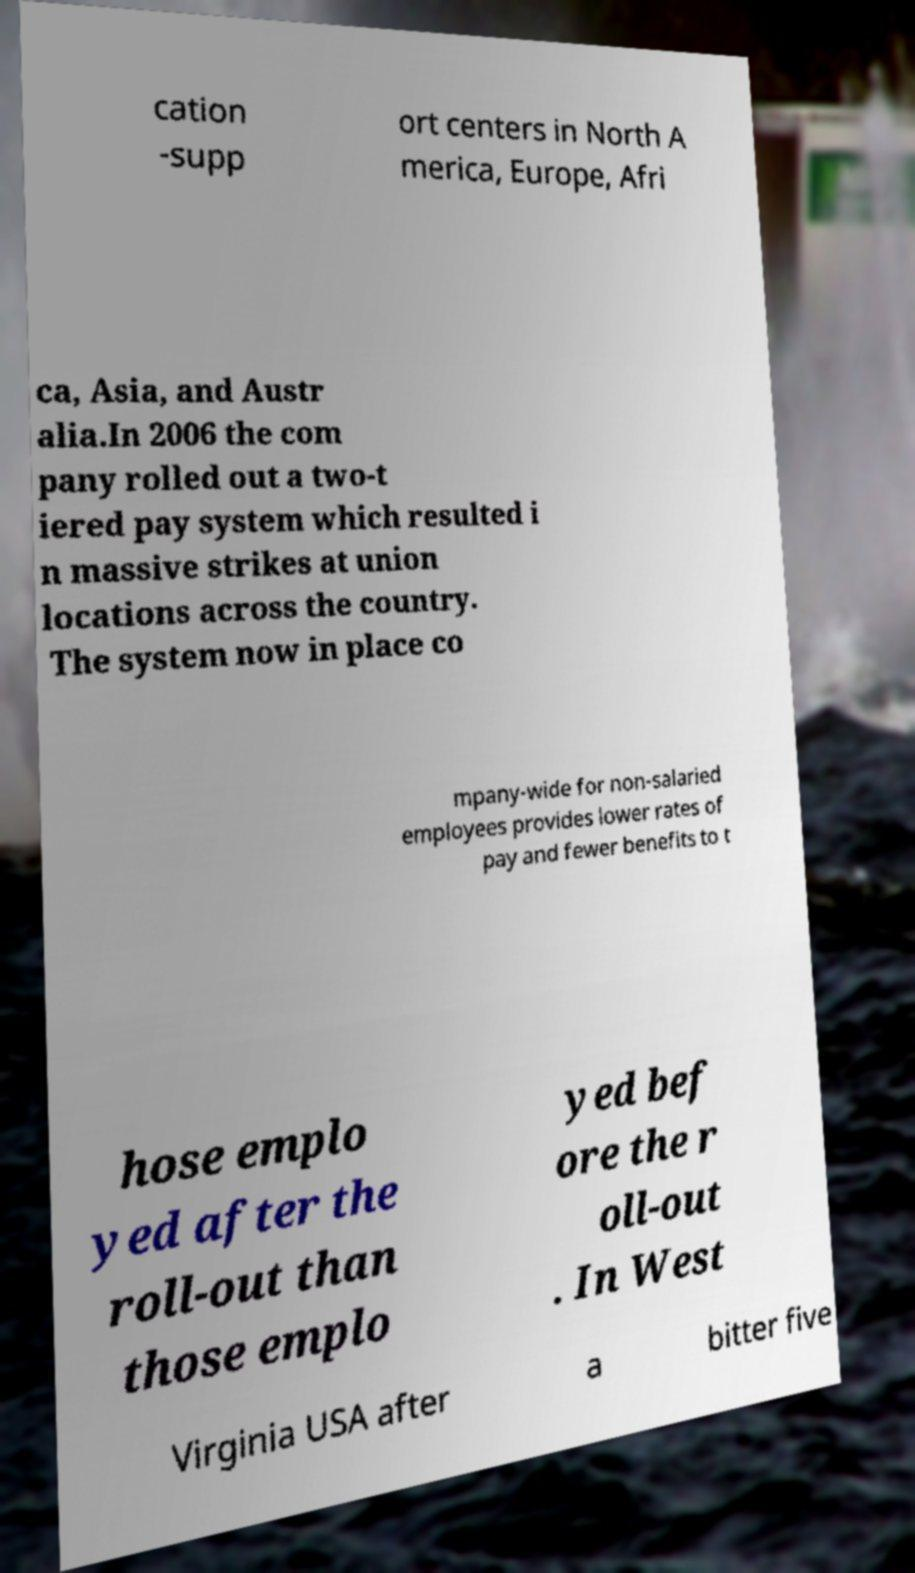Can you read and provide the text displayed in the image?This photo seems to have some interesting text. Can you extract and type it out for me? cation -supp ort centers in North A merica, Europe, Afri ca, Asia, and Austr alia.In 2006 the com pany rolled out a two-t iered pay system which resulted i n massive strikes at union locations across the country. The system now in place co mpany-wide for non-salaried employees provides lower rates of pay and fewer benefits to t hose emplo yed after the roll-out than those emplo yed bef ore the r oll-out . In West Virginia USA after a bitter five 